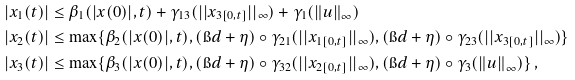<formula> <loc_0><loc_0><loc_500><loc_500>| x _ { 1 } ( t ) | & \leq \beta _ { 1 } ( | x ( 0 ) | , t ) + \gamma _ { 1 3 } ( | | x _ { 3 [ 0 , t ] } | | _ { \infty } ) + \gamma _ { 1 } ( { \| u \| } _ { \infty } ) \\ | x _ { 2 } ( t ) | & \leq \max \{ \beta _ { 2 } ( | x ( 0 ) | , t ) , ( \i d + \eta ) \circ \gamma _ { 2 1 } ( | | x _ { 1 [ 0 , t ] } | | _ { \infty } ) , ( \i d + \eta ) \circ \gamma _ { 2 3 } ( | | x _ { 3 [ 0 , t ] } | | _ { \infty } ) \} \\ | x _ { 3 } ( t ) | & \leq \max \{ \beta _ { 3 } ( | x ( 0 ) | , t ) , ( \i d + \eta ) \circ \gamma _ { 3 2 } ( | | x _ { 2 [ 0 , t ] } | | _ { \infty } ) , ( \i d + \eta ) \circ \gamma _ { 3 } ( { \| u \| } _ { \infty } ) \} \, ,</formula> 